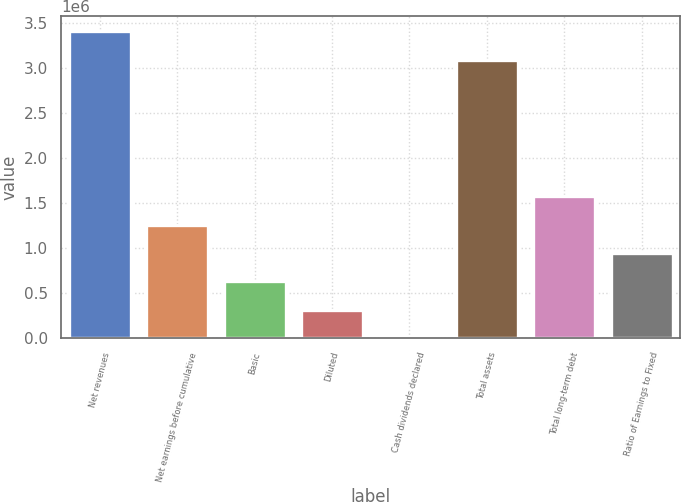<chart> <loc_0><loc_0><loc_500><loc_500><bar_chart><fcel>Net revenues<fcel>Net earnings before cumulative<fcel>Basic<fcel>Diluted<fcel>Cash dividends declared<fcel>Total assets<fcel>Total long-term debt<fcel>Ratio of Earnings to Fixed<nl><fcel>3.41205e+06<fcel>1.26059e+06<fcel>630297<fcel>315149<fcel>0.48<fcel>3.0969e+06<fcel>1.57574e+06<fcel>945445<nl></chart> 